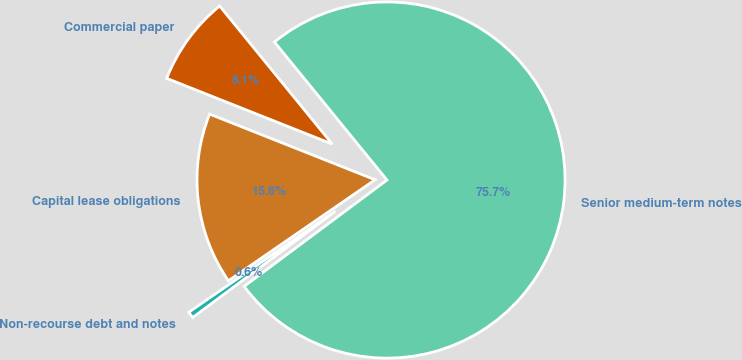<chart> <loc_0><loc_0><loc_500><loc_500><pie_chart><fcel>Senior medium-term notes<fcel>Commercial paper<fcel>Capital lease obligations<fcel>Non-recourse debt and notes<nl><fcel>75.7%<fcel>8.1%<fcel>15.61%<fcel>0.59%<nl></chart> 